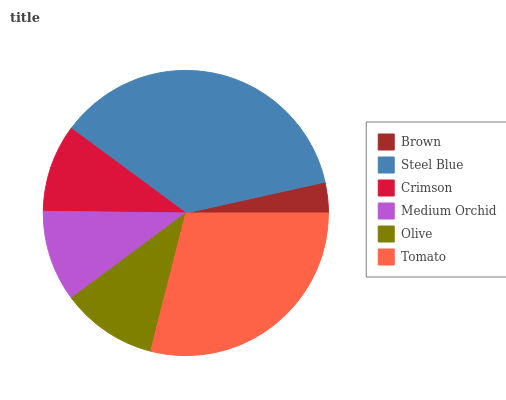Is Brown the minimum?
Answer yes or no. Yes. Is Steel Blue the maximum?
Answer yes or no. Yes. Is Crimson the minimum?
Answer yes or no. No. Is Crimson the maximum?
Answer yes or no. No. Is Steel Blue greater than Crimson?
Answer yes or no. Yes. Is Crimson less than Steel Blue?
Answer yes or no. Yes. Is Crimson greater than Steel Blue?
Answer yes or no. No. Is Steel Blue less than Crimson?
Answer yes or no. No. Is Olive the high median?
Answer yes or no. Yes. Is Medium Orchid the low median?
Answer yes or no. Yes. Is Crimson the high median?
Answer yes or no. No. Is Crimson the low median?
Answer yes or no. No. 